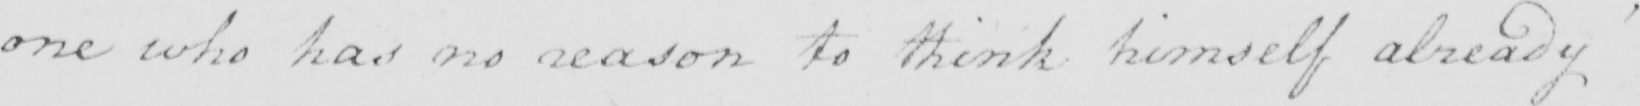Can you tell me what this handwritten text says? one who has no reason to think himself already 